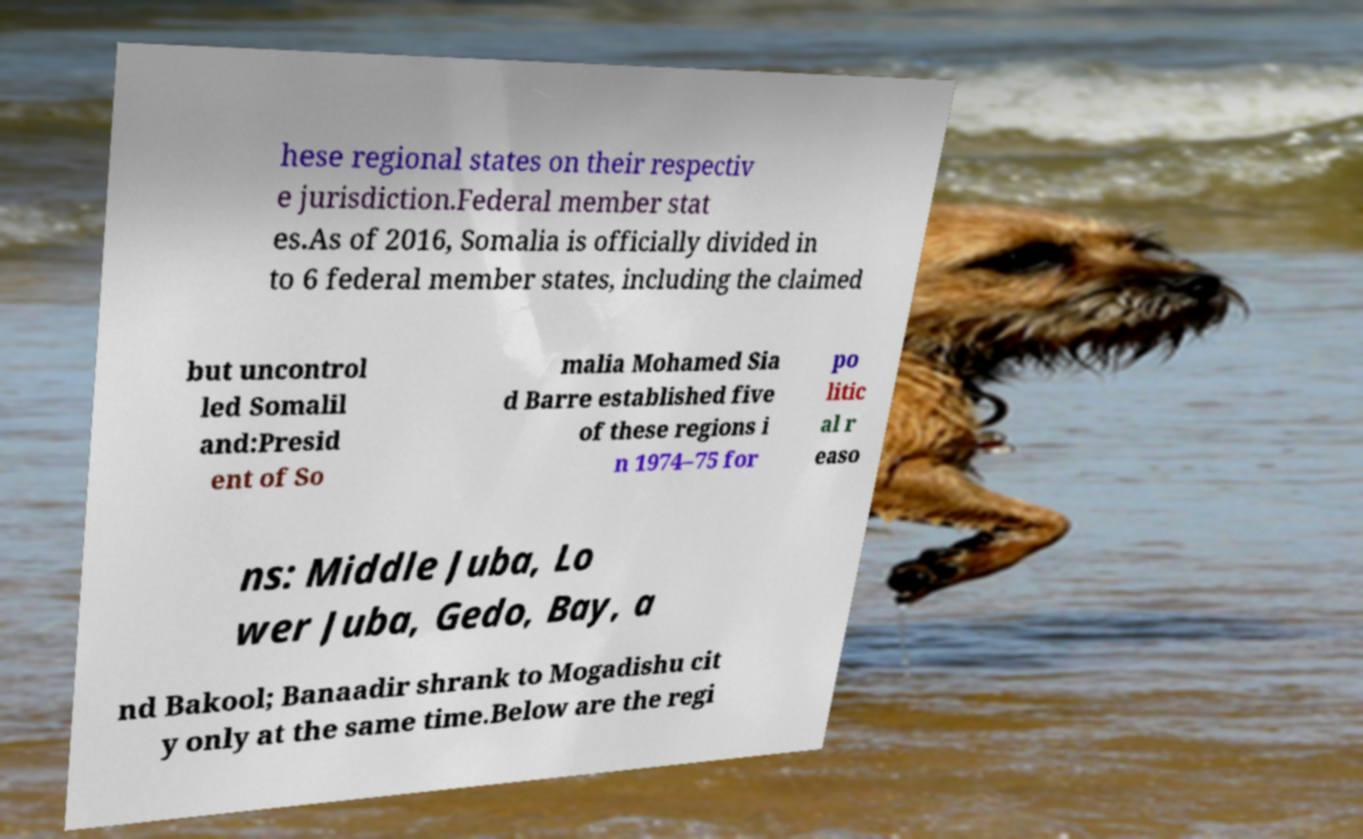Please read and relay the text visible in this image. What does it say? hese regional states on their respectiv e jurisdiction.Federal member stat es.As of 2016, Somalia is officially divided in to 6 federal member states, including the claimed but uncontrol led Somalil and:Presid ent of So malia Mohamed Sia d Barre established five of these regions i n 1974–75 for po litic al r easo ns: Middle Juba, Lo wer Juba, Gedo, Bay, a nd Bakool; Banaadir shrank to Mogadishu cit y only at the same time.Below are the regi 